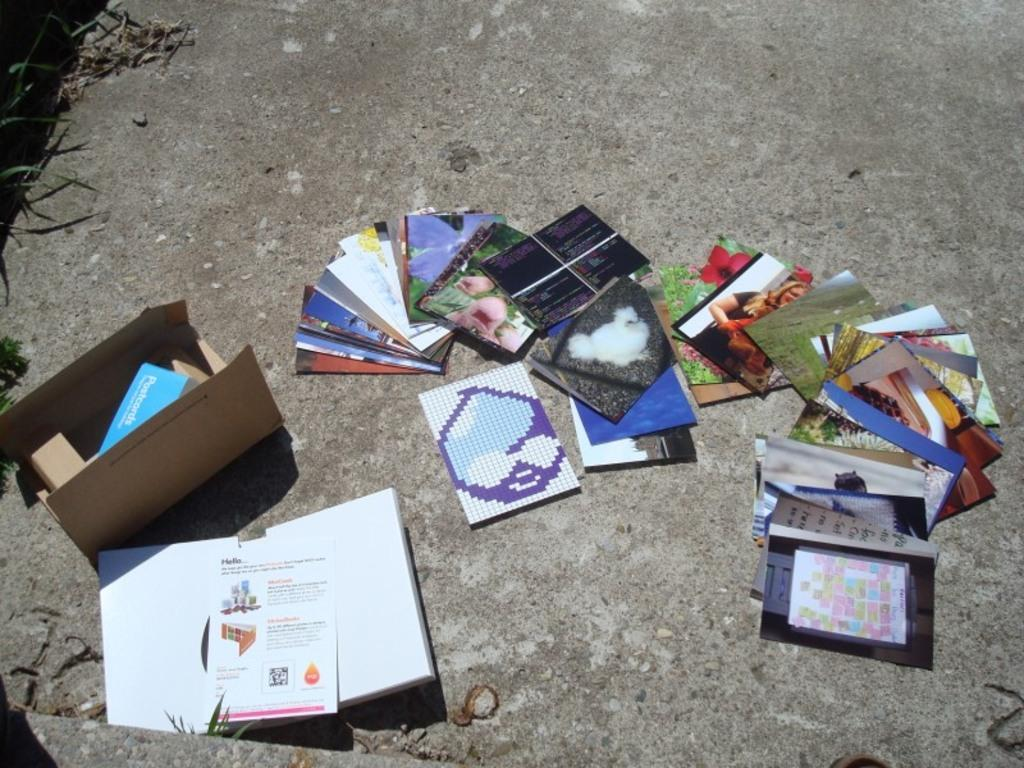What type of items can be seen in the image? There are photos, a cardboard box, and a book in the image. What is the cardboard box containing? There is an object inside the cardboard box. What is the landscape like in the image? There are objects on the land in the image, and there is grass on the left side of the land. Can you describe the haircut of the person holding the pencil in the image? There is no person holding a pencil in the image, and therefore no haircut can be described. 